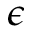Convert formula to latex. <formula><loc_0><loc_0><loc_500><loc_500>\epsilon</formula> 